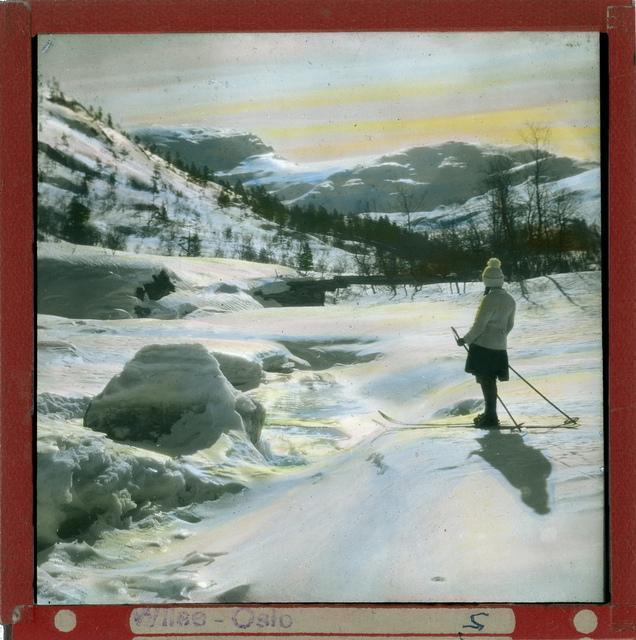How many trucks are in the picture?
Give a very brief answer. 0. 